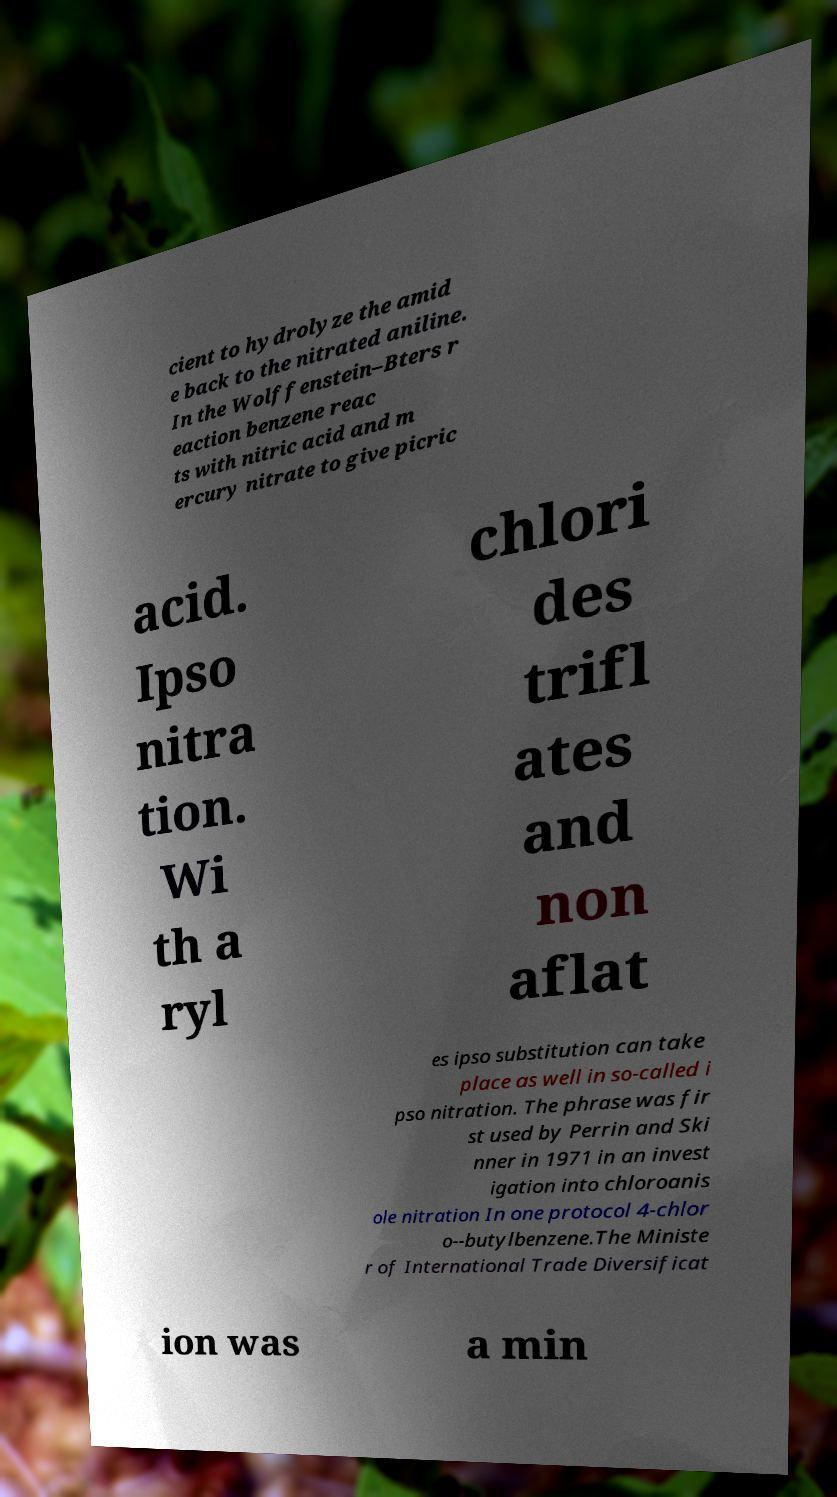There's text embedded in this image that I need extracted. Can you transcribe it verbatim? cient to hydrolyze the amid e back to the nitrated aniline. In the Wolffenstein–Bters r eaction benzene reac ts with nitric acid and m ercury nitrate to give picric acid. Ipso nitra tion. Wi th a ryl chlori des trifl ates and non aflat es ipso substitution can take place as well in so-called i pso nitration. The phrase was fir st used by Perrin and Ski nner in 1971 in an invest igation into chloroanis ole nitration In one protocol 4-chlor o--butylbenzene.The Ministe r of International Trade Diversificat ion was a min 